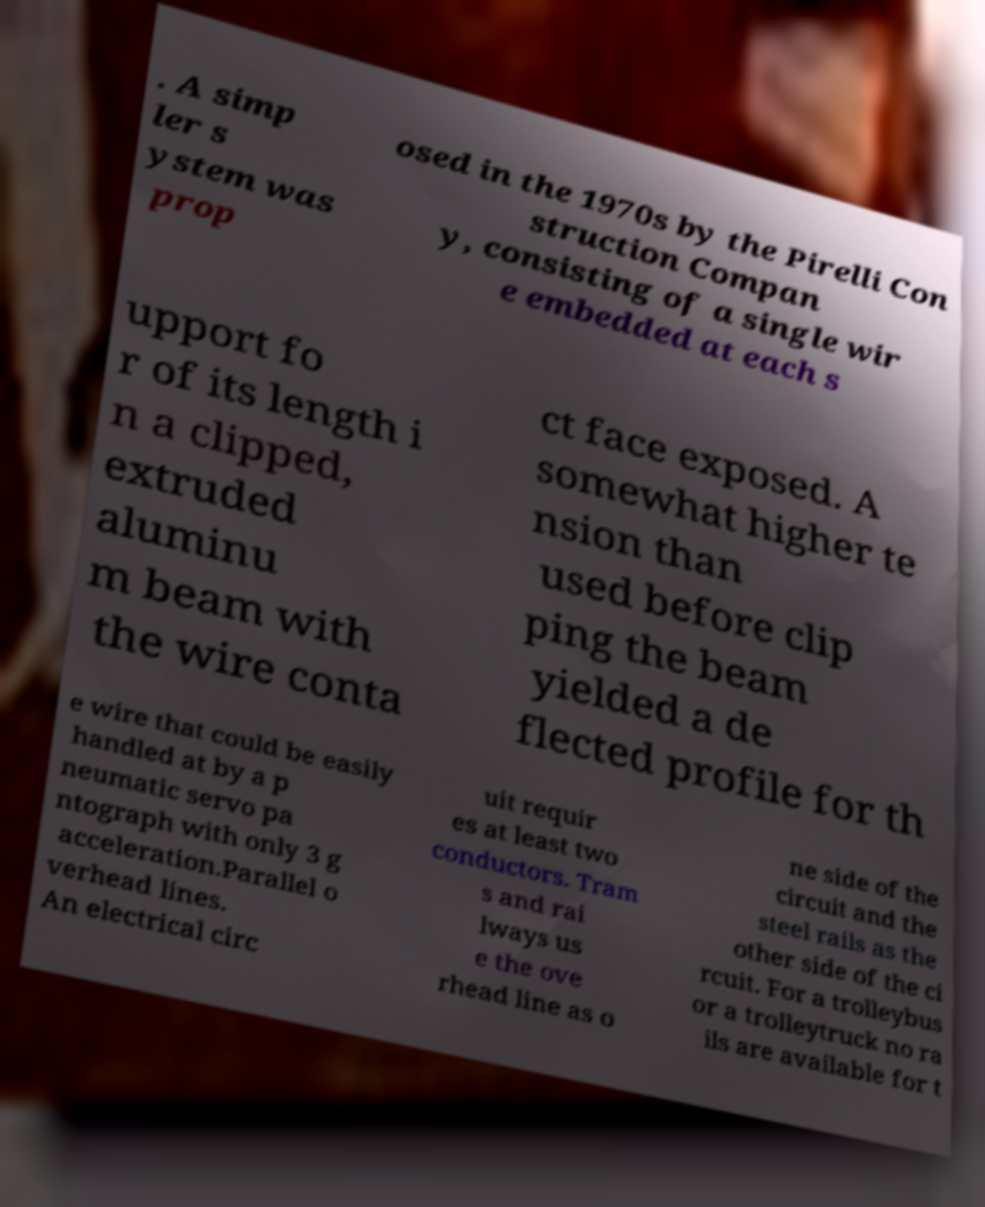I need the written content from this picture converted into text. Can you do that? . A simp ler s ystem was prop osed in the 1970s by the Pirelli Con struction Compan y, consisting of a single wir e embedded at each s upport fo r of its length i n a clipped, extruded aluminu m beam with the wire conta ct face exposed. A somewhat higher te nsion than used before clip ping the beam yielded a de flected profile for th e wire that could be easily handled at by a p neumatic servo pa ntograph with only 3 g acceleration.Parallel o verhead lines. An electrical circ uit requir es at least two conductors. Tram s and rai lways us e the ove rhead line as o ne side of the circuit and the steel rails as the other side of the ci rcuit. For a trolleybus or a trolleytruck no ra ils are available for t 